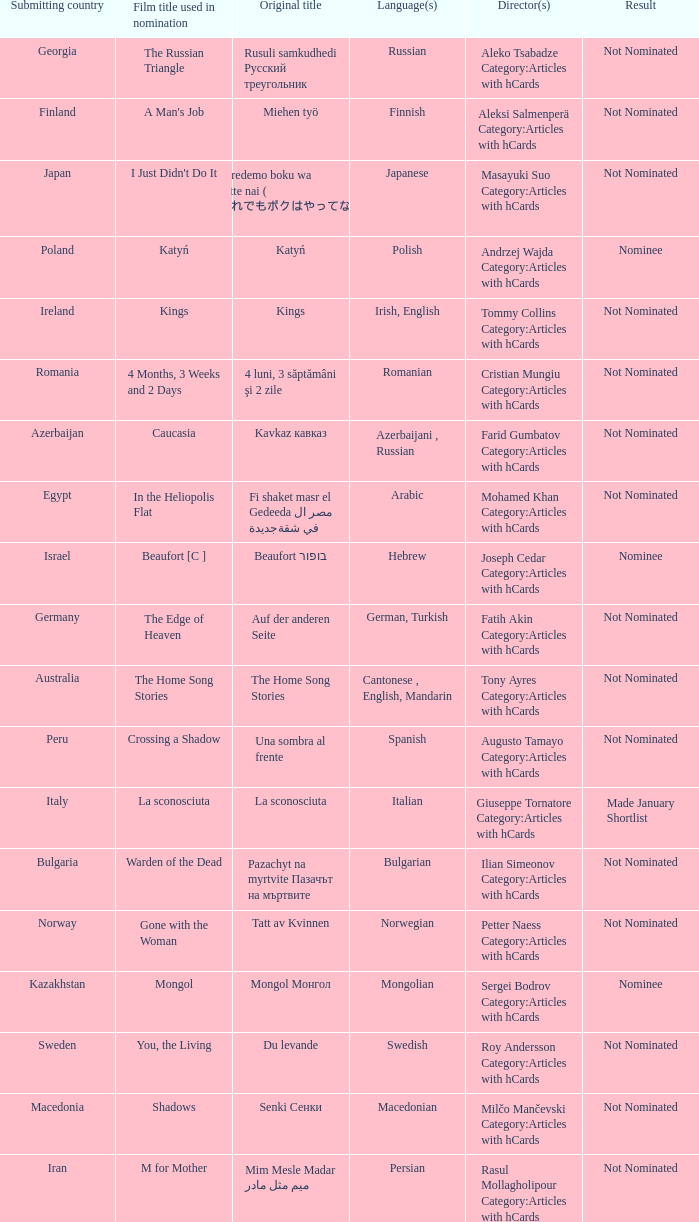What country submitted miehen työ? Finland. 